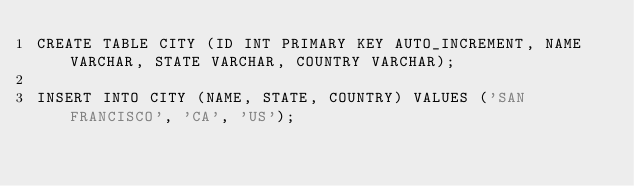<code> <loc_0><loc_0><loc_500><loc_500><_SQL_>CREATE TABLE CITY (ID INT PRIMARY KEY AUTO_INCREMENT, NAME VARCHAR, STATE VARCHAR, COUNTRY VARCHAR);

INSERT INTO CITY (NAME, STATE, COUNTRY) VALUES ('SAN FRANCISCO', 'CA', 'US');
</code> 